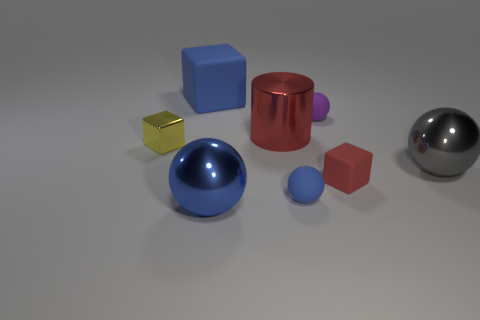What is the color of the small matte block?
Ensure brevity in your answer.  Red. There is a large thing behind the large cylinder; does it have the same shape as the tiny red rubber thing?
Your answer should be compact. Yes. The tiny object that is on the right side of the purple matte thing that is behind the matte sphere in front of the gray shiny thing is what shape?
Ensure brevity in your answer.  Cube. There is a big object in front of the gray sphere; what material is it?
Your answer should be very brief. Metal. The cylinder that is the same size as the gray metallic sphere is what color?
Keep it short and to the point. Red. How many other objects are the same shape as the tiny blue thing?
Provide a succinct answer. 3. Does the blue block have the same size as the gray metal thing?
Offer a terse response. Yes. Is the number of big objects in front of the tiny yellow metal thing greater than the number of red metallic objects on the left side of the blue matte cube?
Make the answer very short. Yes. How many other objects are the same size as the purple sphere?
Provide a succinct answer. 3. Do the big metallic ball on the left side of the purple ball and the big matte block have the same color?
Offer a very short reply. Yes. 